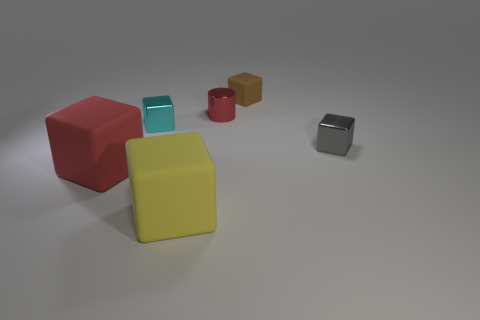Subtract all yellow matte cubes. How many cubes are left? 4 Subtract all red blocks. How many blocks are left? 4 Subtract all green cubes. Subtract all purple cylinders. How many cubes are left? 5 Add 3 small cyan rubber cylinders. How many objects exist? 9 Subtract all cylinders. How many objects are left? 5 Subtract all tiny yellow metallic blocks. Subtract all yellow rubber cubes. How many objects are left? 5 Add 3 red metal things. How many red metal things are left? 4 Add 6 yellow matte things. How many yellow matte things exist? 7 Subtract 0 cyan spheres. How many objects are left? 6 